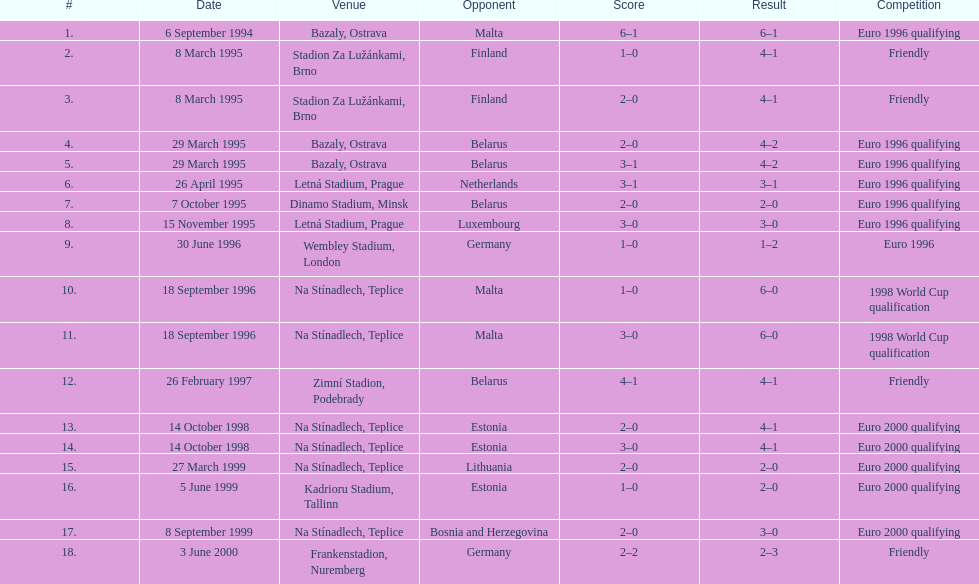What was the number of times czech republic played against germany? 2. 